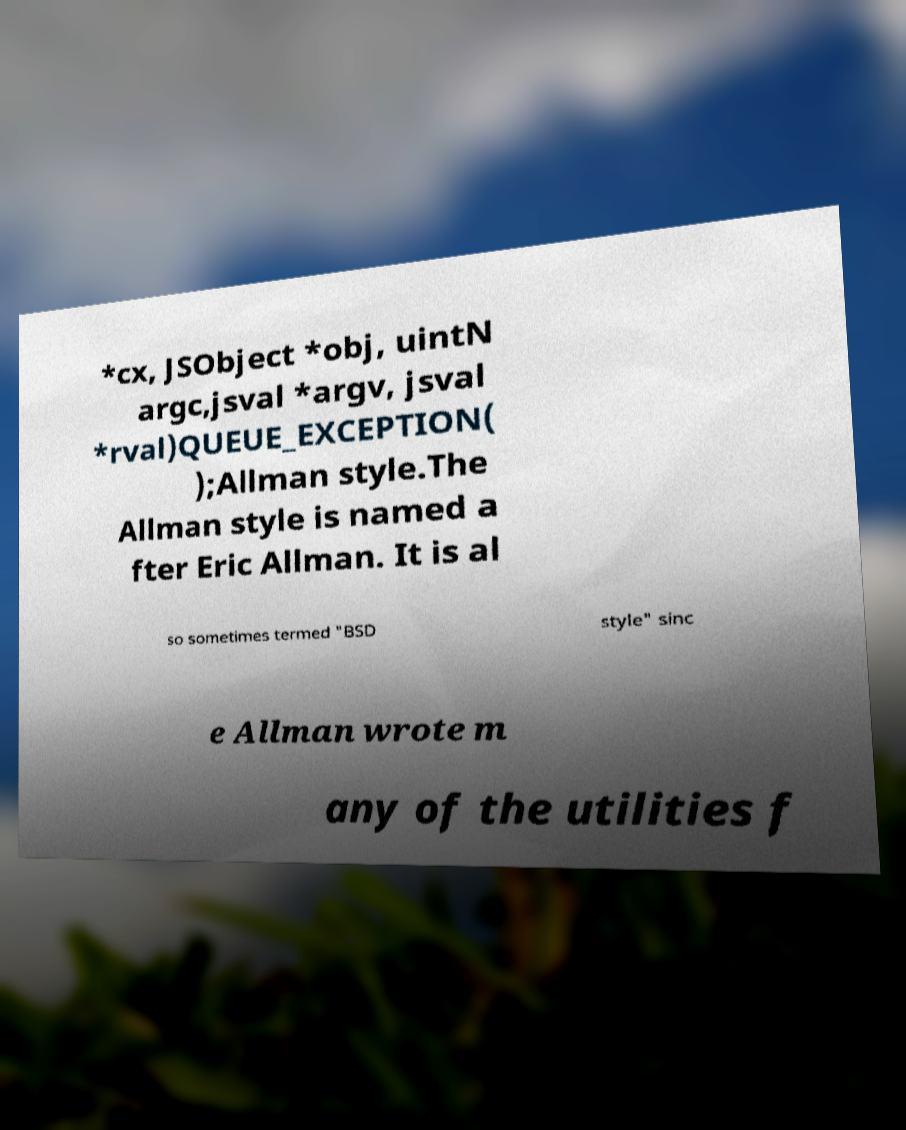There's text embedded in this image that I need extracted. Can you transcribe it verbatim? *cx, JSObject *obj, uintN argc,jsval *argv, jsval *rval)QUEUE_EXCEPTION( );Allman style.The Allman style is named a fter Eric Allman. It is al so sometimes termed "BSD style" sinc e Allman wrote m any of the utilities f 